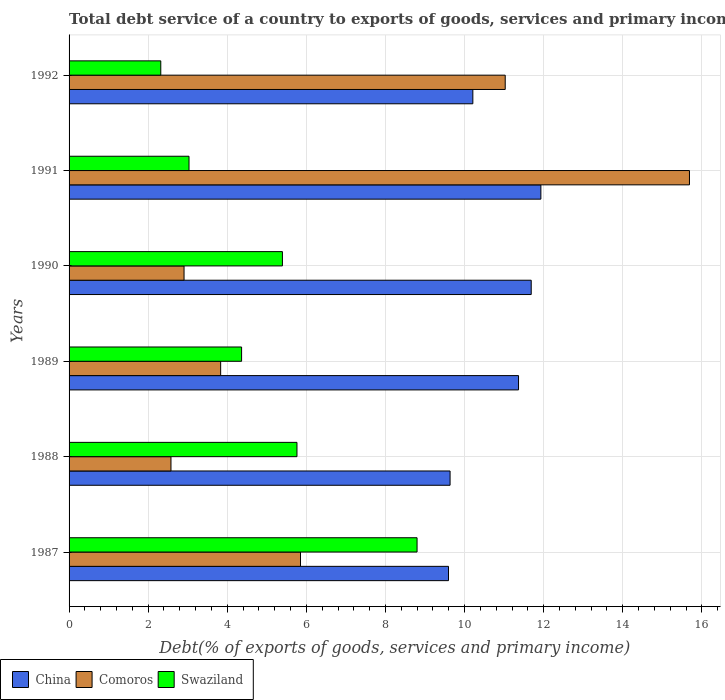Are the number of bars per tick equal to the number of legend labels?
Your response must be concise. Yes. How many bars are there on the 5th tick from the top?
Provide a succinct answer. 3. How many bars are there on the 5th tick from the bottom?
Provide a short and direct response. 3. In how many cases, is the number of bars for a given year not equal to the number of legend labels?
Offer a very short reply. 0. What is the total debt service in Swaziland in 1992?
Provide a succinct answer. 2.32. Across all years, what is the maximum total debt service in Swaziland?
Give a very brief answer. 8.8. Across all years, what is the minimum total debt service in Comoros?
Your answer should be very brief. 2.58. In which year was the total debt service in Swaziland maximum?
Your answer should be compact. 1987. In which year was the total debt service in Swaziland minimum?
Keep it short and to the point. 1992. What is the total total debt service in Swaziland in the graph?
Provide a succinct answer. 29.67. What is the difference between the total debt service in China in 1988 and that in 1991?
Your answer should be compact. -2.3. What is the difference between the total debt service in Comoros in 1987 and the total debt service in Swaziland in 1991?
Your response must be concise. 2.82. What is the average total debt service in China per year?
Provide a succinct answer. 10.74. In the year 1989, what is the difference between the total debt service in Swaziland and total debt service in Comoros?
Give a very brief answer. 0.53. In how many years, is the total debt service in China greater than 13.6 %?
Your answer should be compact. 0. What is the ratio of the total debt service in Comoros in 1988 to that in 1992?
Offer a terse response. 0.23. Is the total debt service in Swaziland in 1988 less than that in 1989?
Provide a short and direct response. No. What is the difference between the highest and the second highest total debt service in Comoros?
Provide a short and direct response. 4.66. What is the difference between the highest and the lowest total debt service in Swaziland?
Your answer should be compact. 6.48. Is the sum of the total debt service in China in 1987 and 1991 greater than the maximum total debt service in Swaziland across all years?
Provide a short and direct response. Yes. What does the 2nd bar from the top in 1988 represents?
Provide a succinct answer. Comoros. What does the 3rd bar from the bottom in 1989 represents?
Offer a very short reply. Swaziland. Does the graph contain grids?
Provide a short and direct response. Yes. How many legend labels are there?
Your answer should be very brief. 3. How are the legend labels stacked?
Keep it short and to the point. Horizontal. What is the title of the graph?
Offer a terse response. Total debt service of a country to exports of goods, services and primary income. Does "Liechtenstein" appear as one of the legend labels in the graph?
Give a very brief answer. No. What is the label or title of the X-axis?
Provide a succinct answer. Debt(% of exports of goods, services and primary income). What is the label or title of the Y-axis?
Ensure brevity in your answer.  Years. What is the Debt(% of exports of goods, services and primary income) in China in 1987?
Offer a very short reply. 9.59. What is the Debt(% of exports of goods, services and primary income) of Comoros in 1987?
Offer a very short reply. 5.85. What is the Debt(% of exports of goods, services and primary income) in Swaziland in 1987?
Your answer should be compact. 8.8. What is the Debt(% of exports of goods, services and primary income) of China in 1988?
Offer a very short reply. 9.63. What is the Debt(% of exports of goods, services and primary income) of Comoros in 1988?
Provide a short and direct response. 2.58. What is the Debt(% of exports of goods, services and primary income) of Swaziland in 1988?
Provide a short and direct response. 5.76. What is the Debt(% of exports of goods, services and primary income) in China in 1989?
Your response must be concise. 11.36. What is the Debt(% of exports of goods, services and primary income) in Comoros in 1989?
Offer a very short reply. 3.83. What is the Debt(% of exports of goods, services and primary income) of Swaziland in 1989?
Give a very brief answer. 4.36. What is the Debt(% of exports of goods, services and primary income) in China in 1990?
Make the answer very short. 11.69. What is the Debt(% of exports of goods, services and primary income) in Comoros in 1990?
Offer a very short reply. 2.91. What is the Debt(% of exports of goods, services and primary income) in Swaziland in 1990?
Your answer should be compact. 5.39. What is the Debt(% of exports of goods, services and primary income) of China in 1991?
Provide a succinct answer. 11.93. What is the Debt(% of exports of goods, services and primary income) of Comoros in 1991?
Offer a terse response. 15.69. What is the Debt(% of exports of goods, services and primary income) of Swaziland in 1991?
Your answer should be very brief. 3.03. What is the Debt(% of exports of goods, services and primary income) in China in 1992?
Your answer should be compact. 10.21. What is the Debt(% of exports of goods, services and primary income) in Comoros in 1992?
Your answer should be very brief. 11.03. What is the Debt(% of exports of goods, services and primary income) of Swaziland in 1992?
Make the answer very short. 2.32. Across all years, what is the maximum Debt(% of exports of goods, services and primary income) of China?
Provide a succinct answer. 11.93. Across all years, what is the maximum Debt(% of exports of goods, services and primary income) in Comoros?
Your response must be concise. 15.69. Across all years, what is the maximum Debt(% of exports of goods, services and primary income) of Swaziland?
Offer a terse response. 8.8. Across all years, what is the minimum Debt(% of exports of goods, services and primary income) of China?
Provide a succinct answer. 9.59. Across all years, what is the minimum Debt(% of exports of goods, services and primary income) of Comoros?
Provide a short and direct response. 2.58. Across all years, what is the minimum Debt(% of exports of goods, services and primary income) of Swaziland?
Your response must be concise. 2.32. What is the total Debt(% of exports of goods, services and primary income) in China in the graph?
Your answer should be compact. 64.42. What is the total Debt(% of exports of goods, services and primary income) in Comoros in the graph?
Make the answer very short. 41.88. What is the total Debt(% of exports of goods, services and primary income) in Swaziland in the graph?
Give a very brief answer. 29.67. What is the difference between the Debt(% of exports of goods, services and primary income) of China in 1987 and that in 1988?
Provide a succinct answer. -0.04. What is the difference between the Debt(% of exports of goods, services and primary income) in Comoros in 1987 and that in 1988?
Offer a very short reply. 3.28. What is the difference between the Debt(% of exports of goods, services and primary income) in Swaziland in 1987 and that in 1988?
Give a very brief answer. 3.04. What is the difference between the Debt(% of exports of goods, services and primary income) of China in 1987 and that in 1989?
Ensure brevity in your answer.  -1.77. What is the difference between the Debt(% of exports of goods, services and primary income) in Comoros in 1987 and that in 1989?
Your response must be concise. 2.02. What is the difference between the Debt(% of exports of goods, services and primary income) in Swaziland in 1987 and that in 1989?
Your response must be concise. 4.44. What is the difference between the Debt(% of exports of goods, services and primary income) in China in 1987 and that in 1990?
Offer a very short reply. -2.09. What is the difference between the Debt(% of exports of goods, services and primary income) in Comoros in 1987 and that in 1990?
Offer a very short reply. 2.94. What is the difference between the Debt(% of exports of goods, services and primary income) in Swaziland in 1987 and that in 1990?
Your answer should be compact. 3.4. What is the difference between the Debt(% of exports of goods, services and primary income) in China in 1987 and that in 1991?
Your answer should be very brief. -2.34. What is the difference between the Debt(% of exports of goods, services and primary income) of Comoros in 1987 and that in 1991?
Provide a succinct answer. -9.84. What is the difference between the Debt(% of exports of goods, services and primary income) in Swaziland in 1987 and that in 1991?
Provide a succinct answer. 5.77. What is the difference between the Debt(% of exports of goods, services and primary income) in China in 1987 and that in 1992?
Provide a short and direct response. -0.62. What is the difference between the Debt(% of exports of goods, services and primary income) of Comoros in 1987 and that in 1992?
Your answer should be compact. -5.18. What is the difference between the Debt(% of exports of goods, services and primary income) in Swaziland in 1987 and that in 1992?
Your response must be concise. 6.48. What is the difference between the Debt(% of exports of goods, services and primary income) in China in 1988 and that in 1989?
Provide a succinct answer. -1.73. What is the difference between the Debt(% of exports of goods, services and primary income) in Comoros in 1988 and that in 1989?
Offer a terse response. -1.26. What is the difference between the Debt(% of exports of goods, services and primary income) in Swaziland in 1988 and that in 1989?
Offer a very short reply. 1.4. What is the difference between the Debt(% of exports of goods, services and primary income) of China in 1988 and that in 1990?
Provide a short and direct response. -2.05. What is the difference between the Debt(% of exports of goods, services and primary income) in Comoros in 1988 and that in 1990?
Make the answer very short. -0.33. What is the difference between the Debt(% of exports of goods, services and primary income) in Swaziland in 1988 and that in 1990?
Make the answer very short. 0.37. What is the difference between the Debt(% of exports of goods, services and primary income) of China in 1988 and that in 1991?
Keep it short and to the point. -2.3. What is the difference between the Debt(% of exports of goods, services and primary income) of Comoros in 1988 and that in 1991?
Offer a terse response. -13.11. What is the difference between the Debt(% of exports of goods, services and primary income) of Swaziland in 1988 and that in 1991?
Offer a terse response. 2.73. What is the difference between the Debt(% of exports of goods, services and primary income) of China in 1988 and that in 1992?
Your response must be concise. -0.58. What is the difference between the Debt(% of exports of goods, services and primary income) of Comoros in 1988 and that in 1992?
Offer a very short reply. -8.45. What is the difference between the Debt(% of exports of goods, services and primary income) of Swaziland in 1988 and that in 1992?
Provide a succinct answer. 3.44. What is the difference between the Debt(% of exports of goods, services and primary income) of China in 1989 and that in 1990?
Offer a terse response. -0.32. What is the difference between the Debt(% of exports of goods, services and primary income) of Comoros in 1989 and that in 1990?
Give a very brief answer. 0.93. What is the difference between the Debt(% of exports of goods, services and primary income) of Swaziland in 1989 and that in 1990?
Keep it short and to the point. -1.03. What is the difference between the Debt(% of exports of goods, services and primary income) in China in 1989 and that in 1991?
Ensure brevity in your answer.  -0.56. What is the difference between the Debt(% of exports of goods, services and primary income) of Comoros in 1989 and that in 1991?
Your answer should be very brief. -11.85. What is the difference between the Debt(% of exports of goods, services and primary income) in Swaziland in 1989 and that in 1991?
Give a very brief answer. 1.33. What is the difference between the Debt(% of exports of goods, services and primary income) in China in 1989 and that in 1992?
Give a very brief answer. 1.16. What is the difference between the Debt(% of exports of goods, services and primary income) in Comoros in 1989 and that in 1992?
Make the answer very short. -7.2. What is the difference between the Debt(% of exports of goods, services and primary income) of Swaziland in 1989 and that in 1992?
Keep it short and to the point. 2.04. What is the difference between the Debt(% of exports of goods, services and primary income) in China in 1990 and that in 1991?
Make the answer very short. -0.24. What is the difference between the Debt(% of exports of goods, services and primary income) of Comoros in 1990 and that in 1991?
Your response must be concise. -12.78. What is the difference between the Debt(% of exports of goods, services and primary income) in Swaziland in 1990 and that in 1991?
Offer a very short reply. 2.36. What is the difference between the Debt(% of exports of goods, services and primary income) in China in 1990 and that in 1992?
Your response must be concise. 1.48. What is the difference between the Debt(% of exports of goods, services and primary income) of Comoros in 1990 and that in 1992?
Your answer should be very brief. -8.12. What is the difference between the Debt(% of exports of goods, services and primary income) of Swaziland in 1990 and that in 1992?
Provide a succinct answer. 3.08. What is the difference between the Debt(% of exports of goods, services and primary income) in China in 1991 and that in 1992?
Your response must be concise. 1.72. What is the difference between the Debt(% of exports of goods, services and primary income) of Comoros in 1991 and that in 1992?
Give a very brief answer. 4.66. What is the difference between the Debt(% of exports of goods, services and primary income) of Swaziland in 1991 and that in 1992?
Your answer should be compact. 0.71. What is the difference between the Debt(% of exports of goods, services and primary income) of China in 1987 and the Debt(% of exports of goods, services and primary income) of Comoros in 1988?
Provide a succinct answer. 7.02. What is the difference between the Debt(% of exports of goods, services and primary income) of China in 1987 and the Debt(% of exports of goods, services and primary income) of Swaziland in 1988?
Offer a terse response. 3.83. What is the difference between the Debt(% of exports of goods, services and primary income) of Comoros in 1987 and the Debt(% of exports of goods, services and primary income) of Swaziland in 1988?
Provide a short and direct response. 0.09. What is the difference between the Debt(% of exports of goods, services and primary income) of China in 1987 and the Debt(% of exports of goods, services and primary income) of Comoros in 1989?
Offer a very short reply. 5.76. What is the difference between the Debt(% of exports of goods, services and primary income) of China in 1987 and the Debt(% of exports of goods, services and primary income) of Swaziland in 1989?
Offer a terse response. 5.23. What is the difference between the Debt(% of exports of goods, services and primary income) in Comoros in 1987 and the Debt(% of exports of goods, services and primary income) in Swaziland in 1989?
Keep it short and to the point. 1.49. What is the difference between the Debt(% of exports of goods, services and primary income) of China in 1987 and the Debt(% of exports of goods, services and primary income) of Comoros in 1990?
Offer a very short reply. 6.69. What is the difference between the Debt(% of exports of goods, services and primary income) in China in 1987 and the Debt(% of exports of goods, services and primary income) in Swaziland in 1990?
Give a very brief answer. 4.2. What is the difference between the Debt(% of exports of goods, services and primary income) in Comoros in 1987 and the Debt(% of exports of goods, services and primary income) in Swaziland in 1990?
Offer a terse response. 0.46. What is the difference between the Debt(% of exports of goods, services and primary income) in China in 1987 and the Debt(% of exports of goods, services and primary income) in Comoros in 1991?
Offer a very short reply. -6.09. What is the difference between the Debt(% of exports of goods, services and primary income) of China in 1987 and the Debt(% of exports of goods, services and primary income) of Swaziland in 1991?
Give a very brief answer. 6.56. What is the difference between the Debt(% of exports of goods, services and primary income) of Comoros in 1987 and the Debt(% of exports of goods, services and primary income) of Swaziland in 1991?
Give a very brief answer. 2.82. What is the difference between the Debt(% of exports of goods, services and primary income) of China in 1987 and the Debt(% of exports of goods, services and primary income) of Comoros in 1992?
Keep it short and to the point. -1.43. What is the difference between the Debt(% of exports of goods, services and primary income) in China in 1987 and the Debt(% of exports of goods, services and primary income) in Swaziland in 1992?
Offer a very short reply. 7.28. What is the difference between the Debt(% of exports of goods, services and primary income) in Comoros in 1987 and the Debt(% of exports of goods, services and primary income) in Swaziland in 1992?
Your answer should be very brief. 3.53. What is the difference between the Debt(% of exports of goods, services and primary income) in China in 1988 and the Debt(% of exports of goods, services and primary income) in Comoros in 1989?
Offer a terse response. 5.8. What is the difference between the Debt(% of exports of goods, services and primary income) in China in 1988 and the Debt(% of exports of goods, services and primary income) in Swaziland in 1989?
Offer a very short reply. 5.27. What is the difference between the Debt(% of exports of goods, services and primary income) of Comoros in 1988 and the Debt(% of exports of goods, services and primary income) of Swaziland in 1989?
Your response must be concise. -1.79. What is the difference between the Debt(% of exports of goods, services and primary income) in China in 1988 and the Debt(% of exports of goods, services and primary income) in Comoros in 1990?
Your answer should be very brief. 6.73. What is the difference between the Debt(% of exports of goods, services and primary income) of China in 1988 and the Debt(% of exports of goods, services and primary income) of Swaziland in 1990?
Offer a terse response. 4.24. What is the difference between the Debt(% of exports of goods, services and primary income) of Comoros in 1988 and the Debt(% of exports of goods, services and primary income) of Swaziland in 1990?
Provide a succinct answer. -2.82. What is the difference between the Debt(% of exports of goods, services and primary income) of China in 1988 and the Debt(% of exports of goods, services and primary income) of Comoros in 1991?
Your response must be concise. -6.05. What is the difference between the Debt(% of exports of goods, services and primary income) in China in 1988 and the Debt(% of exports of goods, services and primary income) in Swaziland in 1991?
Ensure brevity in your answer.  6.6. What is the difference between the Debt(% of exports of goods, services and primary income) of Comoros in 1988 and the Debt(% of exports of goods, services and primary income) of Swaziland in 1991?
Provide a short and direct response. -0.46. What is the difference between the Debt(% of exports of goods, services and primary income) of China in 1988 and the Debt(% of exports of goods, services and primary income) of Comoros in 1992?
Make the answer very short. -1.39. What is the difference between the Debt(% of exports of goods, services and primary income) of China in 1988 and the Debt(% of exports of goods, services and primary income) of Swaziland in 1992?
Your answer should be very brief. 7.32. What is the difference between the Debt(% of exports of goods, services and primary income) in Comoros in 1988 and the Debt(% of exports of goods, services and primary income) in Swaziland in 1992?
Your answer should be very brief. 0.26. What is the difference between the Debt(% of exports of goods, services and primary income) in China in 1989 and the Debt(% of exports of goods, services and primary income) in Comoros in 1990?
Make the answer very short. 8.46. What is the difference between the Debt(% of exports of goods, services and primary income) of China in 1989 and the Debt(% of exports of goods, services and primary income) of Swaziland in 1990?
Your answer should be compact. 5.97. What is the difference between the Debt(% of exports of goods, services and primary income) in Comoros in 1989 and the Debt(% of exports of goods, services and primary income) in Swaziland in 1990?
Keep it short and to the point. -1.56. What is the difference between the Debt(% of exports of goods, services and primary income) in China in 1989 and the Debt(% of exports of goods, services and primary income) in Comoros in 1991?
Your answer should be compact. -4.32. What is the difference between the Debt(% of exports of goods, services and primary income) in China in 1989 and the Debt(% of exports of goods, services and primary income) in Swaziland in 1991?
Your response must be concise. 8.33. What is the difference between the Debt(% of exports of goods, services and primary income) of Comoros in 1989 and the Debt(% of exports of goods, services and primary income) of Swaziland in 1991?
Offer a terse response. 0.8. What is the difference between the Debt(% of exports of goods, services and primary income) of China in 1989 and the Debt(% of exports of goods, services and primary income) of Comoros in 1992?
Your response must be concise. 0.34. What is the difference between the Debt(% of exports of goods, services and primary income) of China in 1989 and the Debt(% of exports of goods, services and primary income) of Swaziland in 1992?
Provide a succinct answer. 9.05. What is the difference between the Debt(% of exports of goods, services and primary income) of Comoros in 1989 and the Debt(% of exports of goods, services and primary income) of Swaziland in 1992?
Ensure brevity in your answer.  1.51. What is the difference between the Debt(% of exports of goods, services and primary income) in China in 1990 and the Debt(% of exports of goods, services and primary income) in Comoros in 1991?
Provide a short and direct response. -4. What is the difference between the Debt(% of exports of goods, services and primary income) in China in 1990 and the Debt(% of exports of goods, services and primary income) in Swaziland in 1991?
Offer a terse response. 8.65. What is the difference between the Debt(% of exports of goods, services and primary income) in Comoros in 1990 and the Debt(% of exports of goods, services and primary income) in Swaziland in 1991?
Provide a short and direct response. -0.13. What is the difference between the Debt(% of exports of goods, services and primary income) in China in 1990 and the Debt(% of exports of goods, services and primary income) in Comoros in 1992?
Provide a short and direct response. 0.66. What is the difference between the Debt(% of exports of goods, services and primary income) in China in 1990 and the Debt(% of exports of goods, services and primary income) in Swaziland in 1992?
Provide a short and direct response. 9.37. What is the difference between the Debt(% of exports of goods, services and primary income) in Comoros in 1990 and the Debt(% of exports of goods, services and primary income) in Swaziland in 1992?
Offer a very short reply. 0.59. What is the difference between the Debt(% of exports of goods, services and primary income) in China in 1991 and the Debt(% of exports of goods, services and primary income) in Comoros in 1992?
Ensure brevity in your answer.  0.9. What is the difference between the Debt(% of exports of goods, services and primary income) of China in 1991 and the Debt(% of exports of goods, services and primary income) of Swaziland in 1992?
Your answer should be very brief. 9.61. What is the difference between the Debt(% of exports of goods, services and primary income) in Comoros in 1991 and the Debt(% of exports of goods, services and primary income) in Swaziland in 1992?
Provide a short and direct response. 13.37. What is the average Debt(% of exports of goods, services and primary income) of China per year?
Make the answer very short. 10.74. What is the average Debt(% of exports of goods, services and primary income) in Comoros per year?
Keep it short and to the point. 6.98. What is the average Debt(% of exports of goods, services and primary income) of Swaziland per year?
Offer a terse response. 4.95. In the year 1987, what is the difference between the Debt(% of exports of goods, services and primary income) of China and Debt(% of exports of goods, services and primary income) of Comoros?
Provide a succinct answer. 3.74. In the year 1987, what is the difference between the Debt(% of exports of goods, services and primary income) of China and Debt(% of exports of goods, services and primary income) of Swaziland?
Your answer should be very brief. 0.79. In the year 1987, what is the difference between the Debt(% of exports of goods, services and primary income) of Comoros and Debt(% of exports of goods, services and primary income) of Swaziland?
Provide a short and direct response. -2.95. In the year 1988, what is the difference between the Debt(% of exports of goods, services and primary income) of China and Debt(% of exports of goods, services and primary income) of Comoros?
Offer a very short reply. 7.06. In the year 1988, what is the difference between the Debt(% of exports of goods, services and primary income) in China and Debt(% of exports of goods, services and primary income) in Swaziland?
Your answer should be compact. 3.87. In the year 1988, what is the difference between the Debt(% of exports of goods, services and primary income) in Comoros and Debt(% of exports of goods, services and primary income) in Swaziland?
Make the answer very short. -3.19. In the year 1989, what is the difference between the Debt(% of exports of goods, services and primary income) in China and Debt(% of exports of goods, services and primary income) in Comoros?
Provide a succinct answer. 7.53. In the year 1989, what is the difference between the Debt(% of exports of goods, services and primary income) in China and Debt(% of exports of goods, services and primary income) in Swaziland?
Offer a terse response. 7. In the year 1989, what is the difference between the Debt(% of exports of goods, services and primary income) in Comoros and Debt(% of exports of goods, services and primary income) in Swaziland?
Provide a short and direct response. -0.53. In the year 1990, what is the difference between the Debt(% of exports of goods, services and primary income) in China and Debt(% of exports of goods, services and primary income) in Comoros?
Offer a terse response. 8.78. In the year 1990, what is the difference between the Debt(% of exports of goods, services and primary income) in China and Debt(% of exports of goods, services and primary income) in Swaziland?
Your answer should be very brief. 6.29. In the year 1990, what is the difference between the Debt(% of exports of goods, services and primary income) of Comoros and Debt(% of exports of goods, services and primary income) of Swaziland?
Provide a short and direct response. -2.49. In the year 1991, what is the difference between the Debt(% of exports of goods, services and primary income) of China and Debt(% of exports of goods, services and primary income) of Comoros?
Make the answer very short. -3.76. In the year 1991, what is the difference between the Debt(% of exports of goods, services and primary income) in China and Debt(% of exports of goods, services and primary income) in Swaziland?
Make the answer very short. 8.9. In the year 1991, what is the difference between the Debt(% of exports of goods, services and primary income) in Comoros and Debt(% of exports of goods, services and primary income) in Swaziland?
Make the answer very short. 12.65. In the year 1992, what is the difference between the Debt(% of exports of goods, services and primary income) of China and Debt(% of exports of goods, services and primary income) of Comoros?
Your answer should be very brief. -0.82. In the year 1992, what is the difference between the Debt(% of exports of goods, services and primary income) in China and Debt(% of exports of goods, services and primary income) in Swaziland?
Give a very brief answer. 7.89. In the year 1992, what is the difference between the Debt(% of exports of goods, services and primary income) in Comoros and Debt(% of exports of goods, services and primary income) in Swaziland?
Make the answer very short. 8.71. What is the ratio of the Debt(% of exports of goods, services and primary income) of Comoros in 1987 to that in 1988?
Ensure brevity in your answer.  2.27. What is the ratio of the Debt(% of exports of goods, services and primary income) of Swaziland in 1987 to that in 1988?
Provide a short and direct response. 1.53. What is the ratio of the Debt(% of exports of goods, services and primary income) in China in 1987 to that in 1989?
Provide a short and direct response. 0.84. What is the ratio of the Debt(% of exports of goods, services and primary income) of Comoros in 1987 to that in 1989?
Your answer should be compact. 1.53. What is the ratio of the Debt(% of exports of goods, services and primary income) of Swaziland in 1987 to that in 1989?
Make the answer very short. 2.02. What is the ratio of the Debt(% of exports of goods, services and primary income) in China in 1987 to that in 1990?
Provide a short and direct response. 0.82. What is the ratio of the Debt(% of exports of goods, services and primary income) in Comoros in 1987 to that in 1990?
Provide a short and direct response. 2.01. What is the ratio of the Debt(% of exports of goods, services and primary income) in Swaziland in 1987 to that in 1990?
Keep it short and to the point. 1.63. What is the ratio of the Debt(% of exports of goods, services and primary income) in China in 1987 to that in 1991?
Keep it short and to the point. 0.8. What is the ratio of the Debt(% of exports of goods, services and primary income) in Comoros in 1987 to that in 1991?
Provide a succinct answer. 0.37. What is the ratio of the Debt(% of exports of goods, services and primary income) of Swaziland in 1987 to that in 1991?
Provide a short and direct response. 2.9. What is the ratio of the Debt(% of exports of goods, services and primary income) in China in 1987 to that in 1992?
Make the answer very short. 0.94. What is the ratio of the Debt(% of exports of goods, services and primary income) in Comoros in 1987 to that in 1992?
Provide a short and direct response. 0.53. What is the ratio of the Debt(% of exports of goods, services and primary income) in Swaziland in 1987 to that in 1992?
Your answer should be compact. 3.79. What is the ratio of the Debt(% of exports of goods, services and primary income) in China in 1988 to that in 1989?
Offer a very short reply. 0.85. What is the ratio of the Debt(% of exports of goods, services and primary income) in Comoros in 1988 to that in 1989?
Your response must be concise. 0.67. What is the ratio of the Debt(% of exports of goods, services and primary income) in Swaziland in 1988 to that in 1989?
Give a very brief answer. 1.32. What is the ratio of the Debt(% of exports of goods, services and primary income) of China in 1988 to that in 1990?
Your answer should be compact. 0.82. What is the ratio of the Debt(% of exports of goods, services and primary income) in Comoros in 1988 to that in 1990?
Keep it short and to the point. 0.89. What is the ratio of the Debt(% of exports of goods, services and primary income) of Swaziland in 1988 to that in 1990?
Your answer should be compact. 1.07. What is the ratio of the Debt(% of exports of goods, services and primary income) in China in 1988 to that in 1991?
Provide a short and direct response. 0.81. What is the ratio of the Debt(% of exports of goods, services and primary income) of Comoros in 1988 to that in 1991?
Keep it short and to the point. 0.16. What is the ratio of the Debt(% of exports of goods, services and primary income) of Swaziland in 1988 to that in 1991?
Make the answer very short. 1.9. What is the ratio of the Debt(% of exports of goods, services and primary income) in China in 1988 to that in 1992?
Keep it short and to the point. 0.94. What is the ratio of the Debt(% of exports of goods, services and primary income) in Comoros in 1988 to that in 1992?
Provide a short and direct response. 0.23. What is the ratio of the Debt(% of exports of goods, services and primary income) of Swaziland in 1988 to that in 1992?
Your answer should be very brief. 2.48. What is the ratio of the Debt(% of exports of goods, services and primary income) in China in 1989 to that in 1990?
Keep it short and to the point. 0.97. What is the ratio of the Debt(% of exports of goods, services and primary income) in Comoros in 1989 to that in 1990?
Provide a succinct answer. 1.32. What is the ratio of the Debt(% of exports of goods, services and primary income) in Swaziland in 1989 to that in 1990?
Offer a terse response. 0.81. What is the ratio of the Debt(% of exports of goods, services and primary income) of China in 1989 to that in 1991?
Provide a succinct answer. 0.95. What is the ratio of the Debt(% of exports of goods, services and primary income) in Comoros in 1989 to that in 1991?
Offer a very short reply. 0.24. What is the ratio of the Debt(% of exports of goods, services and primary income) in Swaziland in 1989 to that in 1991?
Offer a very short reply. 1.44. What is the ratio of the Debt(% of exports of goods, services and primary income) of China in 1989 to that in 1992?
Provide a short and direct response. 1.11. What is the ratio of the Debt(% of exports of goods, services and primary income) of Comoros in 1989 to that in 1992?
Provide a short and direct response. 0.35. What is the ratio of the Debt(% of exports of goods, services and primary income) of Swaziland in 1989 to that in 1992?
Your answer should be very brief. 1.88. What is the ratio of the Debt(% of exports of goods, services and primary income) of China in 1990 to that in 1991?
Your answer should be very brief. 0.98. What is the ratio of the Debt(% of exports of goods, services and primary income) of Comoros in 1990 to that in 1991?
Ensure brevity in your answer.  0.19. What is the ratio of the Debt(% of exports of goods, services and primary income) in Swaziland in 1990 to that in 1991?
Keep it short and to the point. 1.78. What is the ratio of the Debt(% of exports of goods, services and primary income) of China in 1990 to that in 1992?
Give a very brief answer. 1.14. What is the ratio of the Debt(% of exports of goods, services and primary income) of Comoros in 1990 to that in 1992?
Offer a very short reply. 0.26. What is the ratio of the Debt(% of exports of goods, services and primary income) in Swaziland in 1990 to that in 1992?
Offer a very short reply. 2.33. What is the ratio of the Debt(% of exports of goods, services and primary income) in China in 1991 to that in 1992?
Offer a terse response. 1.17. What is the ratio of the Debt(% of exports of goods, services and primary income) of Comoros in 1991 to that in 1992?
Your answer should be compact. 1.42. What is the ratio of the Debt(% of exports of goods, services and primary income) of Swaziland in 1991 to that in 1992?
Keep it short and to the point. 1.31. What is the difference between the highest and the second highest Debt(% of exports of goods, services and primary income) of China?
Provide a succinct answer. 0.24. What is the difference between the highest and the second highest Debt(% of exports of goods, services and primary income) of Comoros?
Offer a terse response. 4.66. What is the difference between the highest and the second highest Debt(% of exports of goods, services and primary income) of Swaziland?
Ensure brevity in your answer.  3.04. What is the difference between the highest and the lowest Debt(% of exports of goods, services and primary income) of China?
Offer a very short reply. 2.34. What is the difference between the highest and the lowest Debt(% of exports of goods, services and primary income) in Comoros?
Offer a terse response. 13.11. What is the difference between the highest and the lowest Debt(% of exports of goods, services and primary income) in Swaziland?
Your response must be concise. 6.48. 